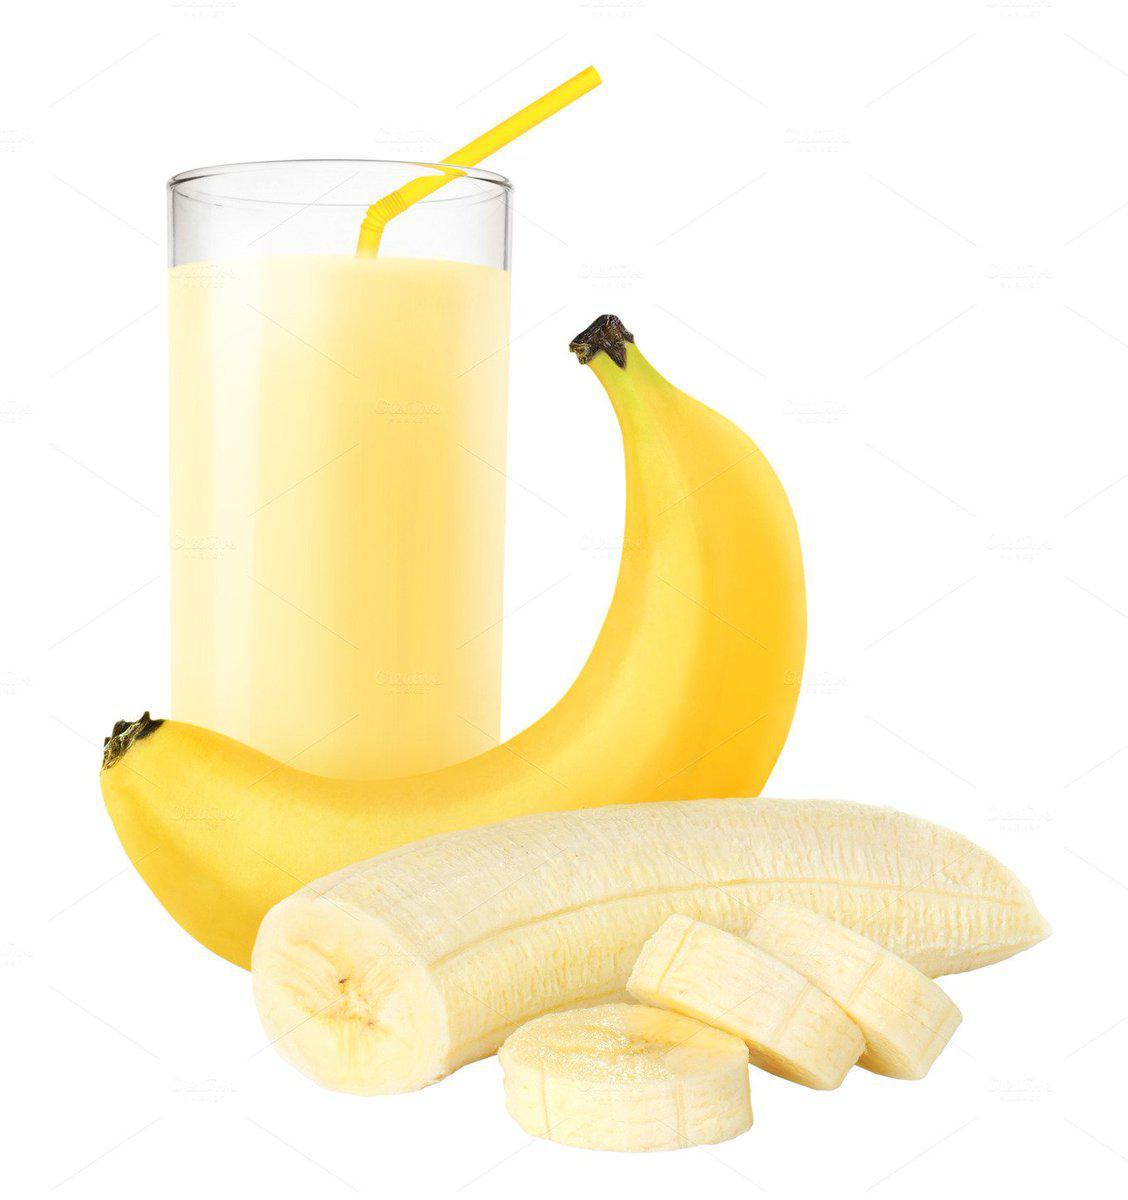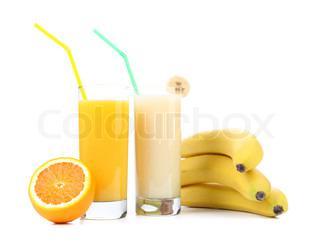The first image is the image on the left, the second image is the image on the right. Evaluate the accuracy of this statement regarding the images: "The right image contains no more than one orange and one banana next to two smoothies.". Is it true? Answer yes or no. No. The first image is the image on the left, the second image is the image on the right. Examine the images to the left and right. Is the description "A pitcher and a glass of the same beverage are behind a small bunch of bananas." accurate? Answer yes or no. No. 